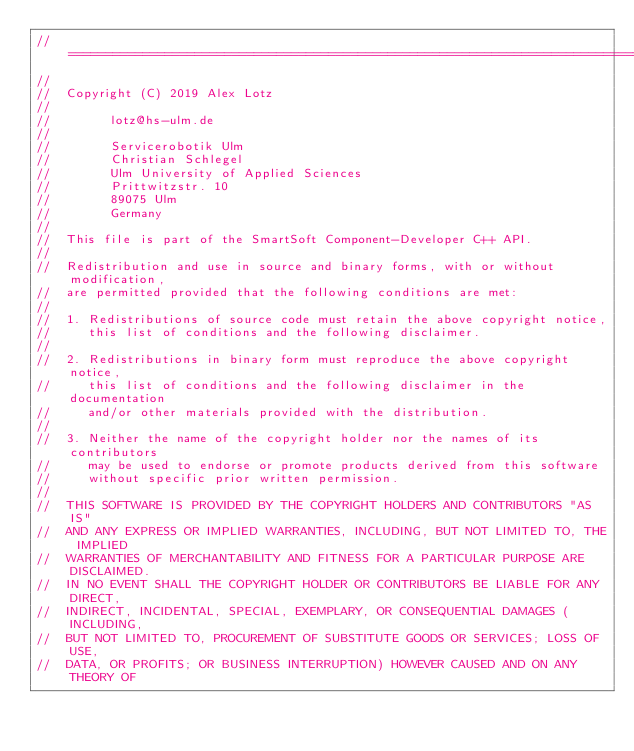<code> <loc_0><loc_0><loc_500><loc_500><_C_>//===================================================================================
//
//  Copyright (C) 2019 Alex Lotz
//
//        lotz@hs-ulm.de
//
//        Servicerobotik Ulm
//        Christian Schlegel
//        Ulm University of Applied Sciences
//        Prittwitzstr. 10
//        89075 Ulm
//        Germany
//
//  This file is part of the SmartSoft Component-Developer C++ API.
//
//  Redistribution and use in source and binary forms, with or without modification,
//  are permitted provided that the following conditions are met:
//
//  1. Redistributions of source code must retain the above copyright notice,
//     this list of conditions and the following disclaimer.
//
//  2. Redistributions in binary form must reproduce the above copyright notice,
//     this list of conditions and the following disclaimer in the documentation
//     and/or other materials provided with the distribution.
//
//  3. Neither the name of the copyright holder nor the names of its contributors
//     may be used to endorse or promote products derived from this software
//     without specific prior written permission.
//
//  THIS SOFTWARE IS PROVIDED BY THE COPYRIGHT HOLDERS AND CONTRIBUTORS "AS IS"
//  AND ANY EXPRESS OR IMPLIED WARRANTIES, INCLUDING, BUT NOT LIMITED TO, THE IMPLIED
//  WARRANTIES OF MERCHANTABILITY AND FITNESS FOR A PARTICULAR PURPOSE ARE DISCLAIMED.
//  IN NO EVENT SHALL THE COPYRIGHT HOLDER OR CONTRIBUTORS BE LIABLE FOR ANY DIRECT,
//  INDIRECT, INCIDENTAL, SPECIAL, EXEMPLARY, OR CONSEQUENTIAL DAMAGES (INCLUDING,
//  BUT NOT LIMITED TO, PROCUREMENT OF SUBSTITUTE GOODS OR SERVICES; LOSS OF USE,
//  DATA, OR PROFITS; OR BUSINESS INTERRUPTION) HOWEVER CAUSED AND ON ANY THEORY OF</code> 